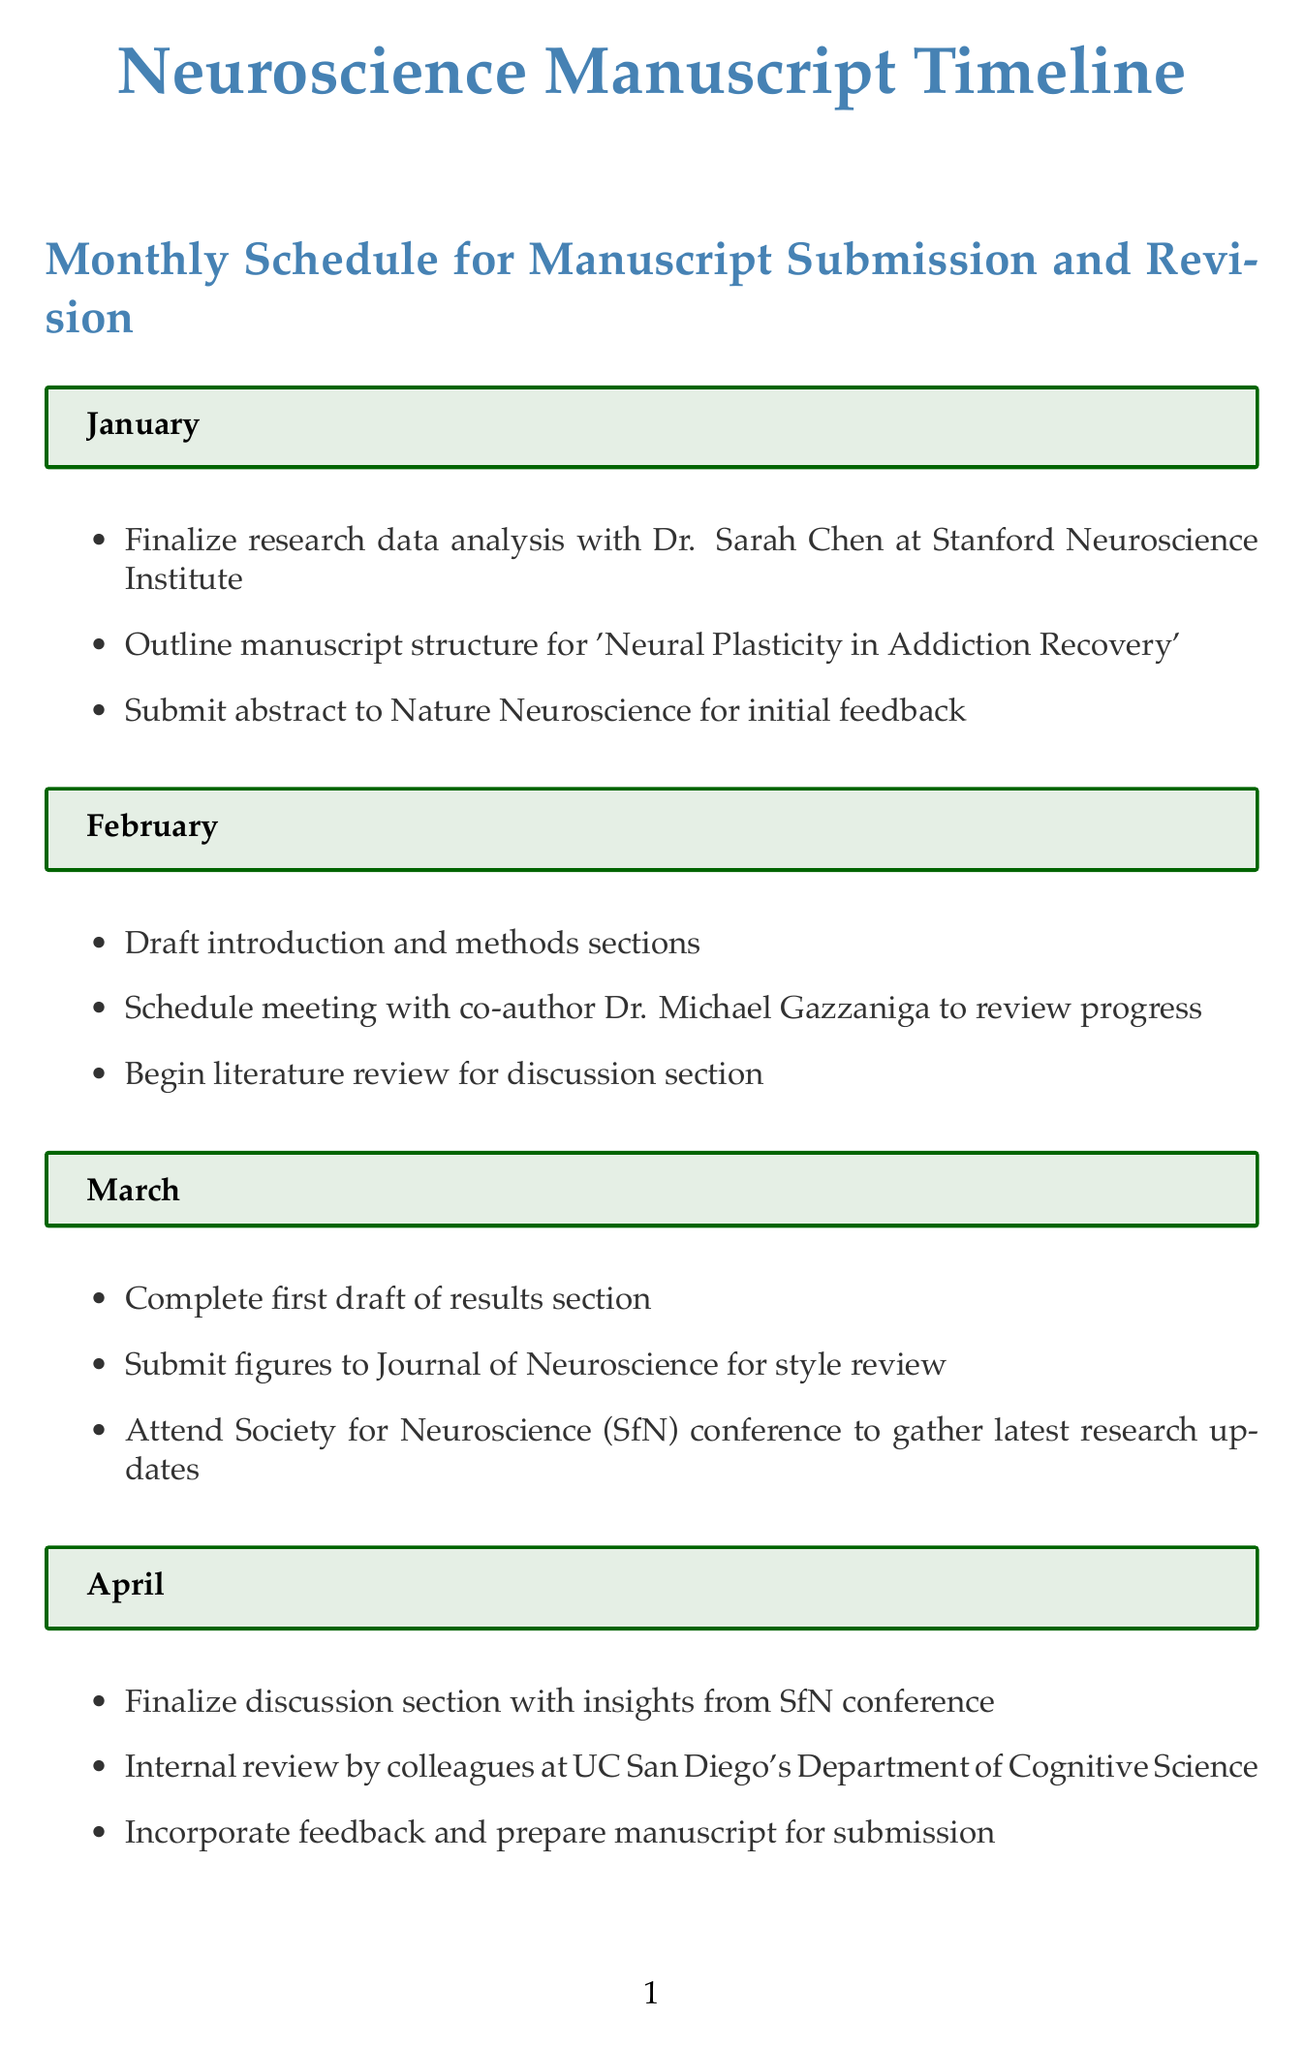What is the title of the manuscript? The title, as mentioned in the outline tasks, is 'Neural Plasticity in Addiction Recovery'.
Answer: 'Neural Plasticity in Addiction Recovery' Who is one of the co-authors mentioned? Dr. Michael Gazzaniga is mentioned in the February tasks for reviewing progress on the manuscript.
Answer: Dr. Michael Gazzaniga In which month is the manuscript submitted to Neuron? The manuscript is submitted in May, as listed in that month's tasks.
Answer: May How many rounds of reviewer comments are received from Neuron? Two rounds of reviewer comments are mentioned in June and August.
Answer: Two rounds What significant event is scheduled for September? The research findings are to be presented at Harvard Medical School's Neurobiology Seminar Series in September.
Answer: Harvard Medical School's Neurobiology Seminar Series What is the final outcome of the manuscript in October? The manuscript is accepted by Neuron, as stated in the October tasks.
Answer: Accepted by Neuron Which publishing house finalizes the book deal in December? The book deal is finalized with Oxford University Press in December.
Answer: Oxford University Press What is the main focus of the book proposal drafted in May? The proposal is based on the research findings from the manuscript work, suggesting a connection to addiction recovery.
Answer: Research findings When is the article published in Neuron? The article is published in December, as indicated in that month's tasks.
Answer: December 